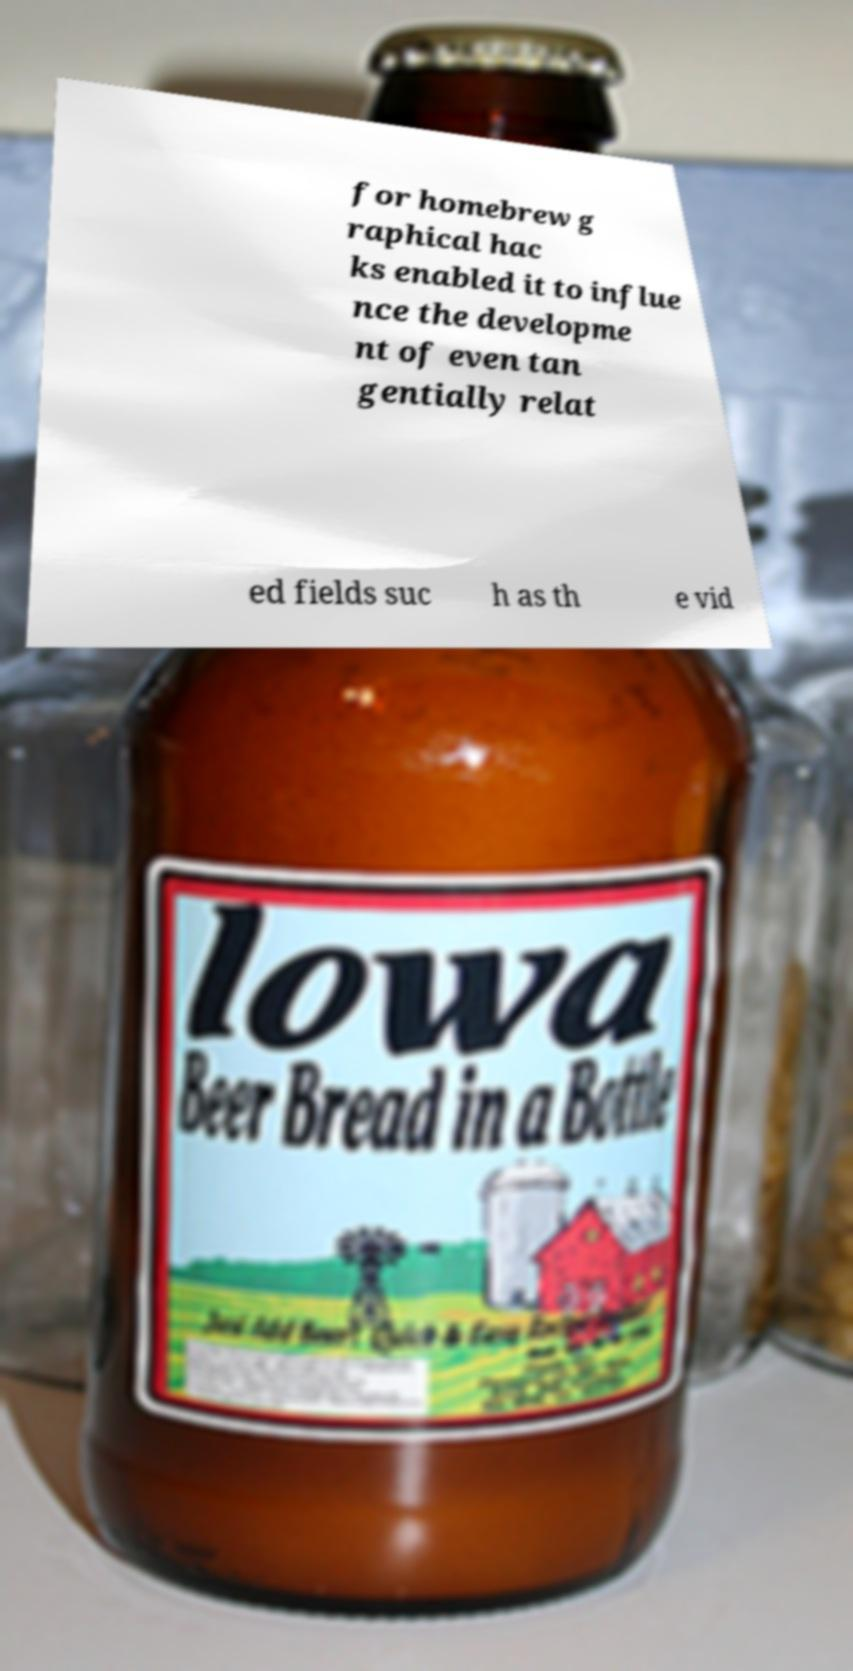What messages or text are displayed in this image? I need them in a readable, typed format. for homebrew g raphical hac ks enabled it to influe nce the developme nt of even tan gentially relat ed fields suc h as th e vid 